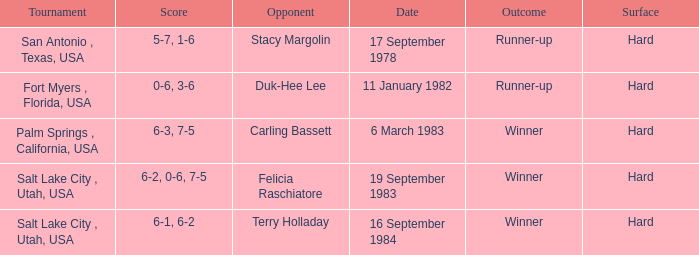Could you help me parse every detail presented in this table? {'header': ['Tournament', 'Score', 'Opponent', 'Date', 'Outcome', 'Surface'], 'rows': [['San Antonio , Texas, USA', '5-7, 1-6', 'Stacy Margolin', '17 September 1978', 'Runner-up', 'Hard'], ['Fort Myers , Florida, USA', '0-6, 3-6', 'Duk-Hee Lee', '11 January 1982', 'Runner-up', 'Hard'], ['Palm Springs , California, USA', '6-3, 7-5', 'Carling Bassett', '6 March 1983', 'Winner', 'Hard'], ['Salt Lake City , Utah, USA', '6-2, 0-6, 7-5', 'Felicia Raschiatore', '19 September 1983', 'Winner', 'Hard'], ['Salt Lake City , Utah, USA', '6-1, 6-2', 'Terry Holladay', '16 September 1984', 'Winner', 'Hard']]} Who was the opponent for the match were the outcome was runner-up and the score was 5-7, 1-6? Stacy Margolin. 